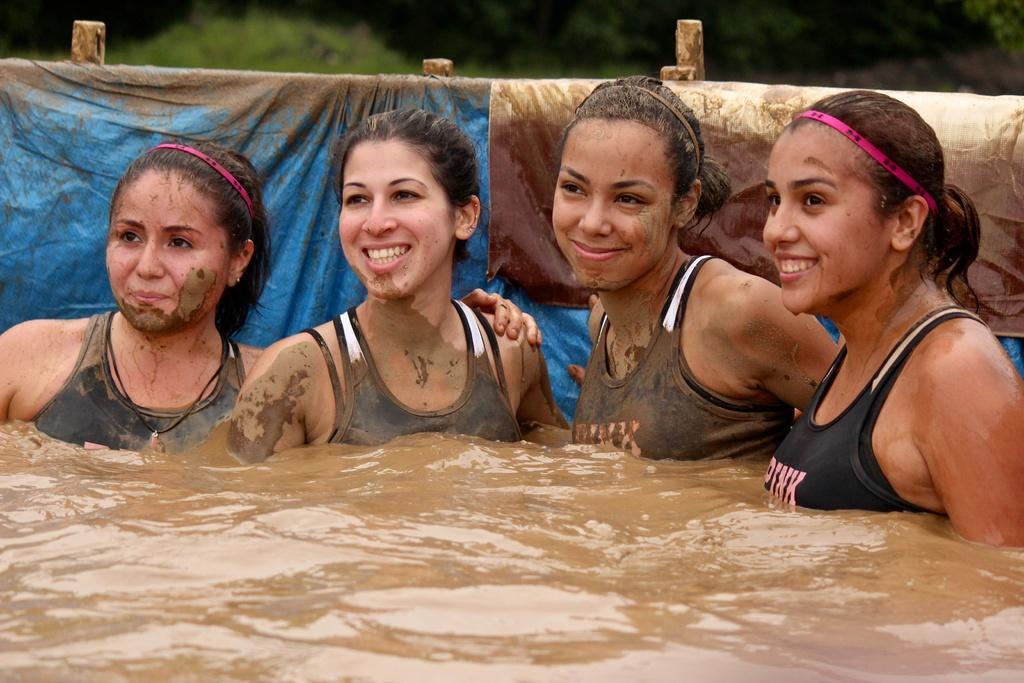Could you give a brief overview of what you see in this image? This picture is clicked outside. In the center we can see the group of women wearing t-shirts and smiling. In the foreground we can see the sludge. In the background we can see the green leaves, curtains and some other objects. 